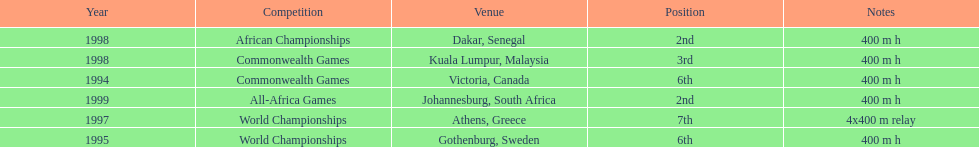In what year did ken harnden participate in more than one competition? 1998. 